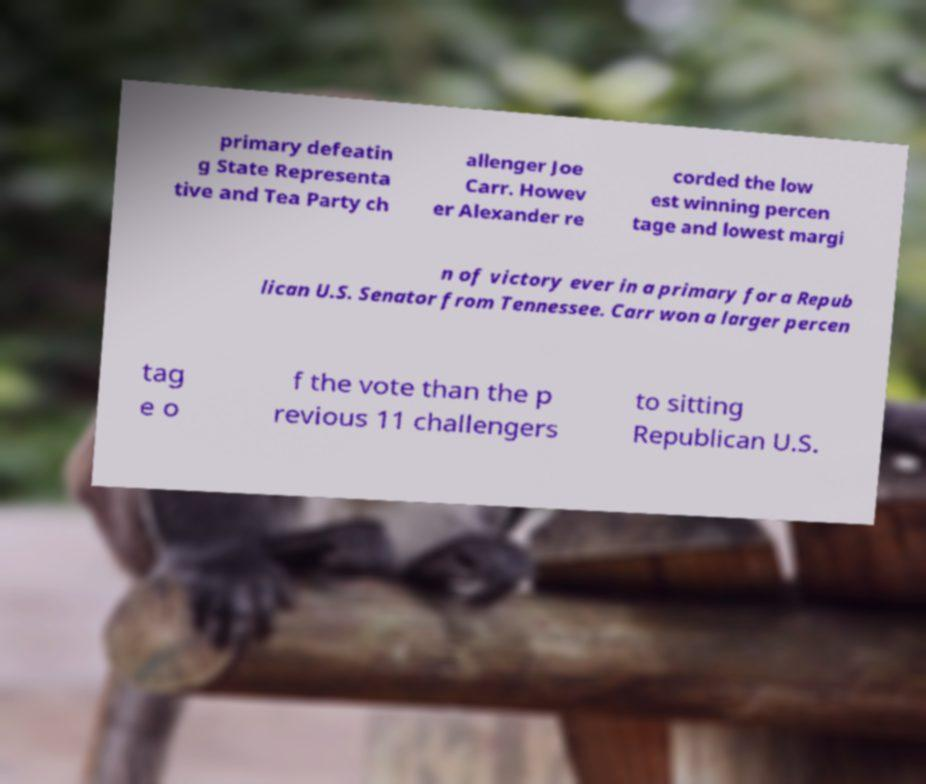Please identify and transcribe the text found in this image. primary defeatin g State Representa tive and Tea Party ch allenger Joe Carr. Howev er Alexander re corded the low est winning percen tage and lowest margi n of victory ever in a primary for a Repub lican U.S. Senator from Tennessee. Carr won a larger percen tag e o f the vote than the p revious 11 challengers to sitting Republican U.S. 